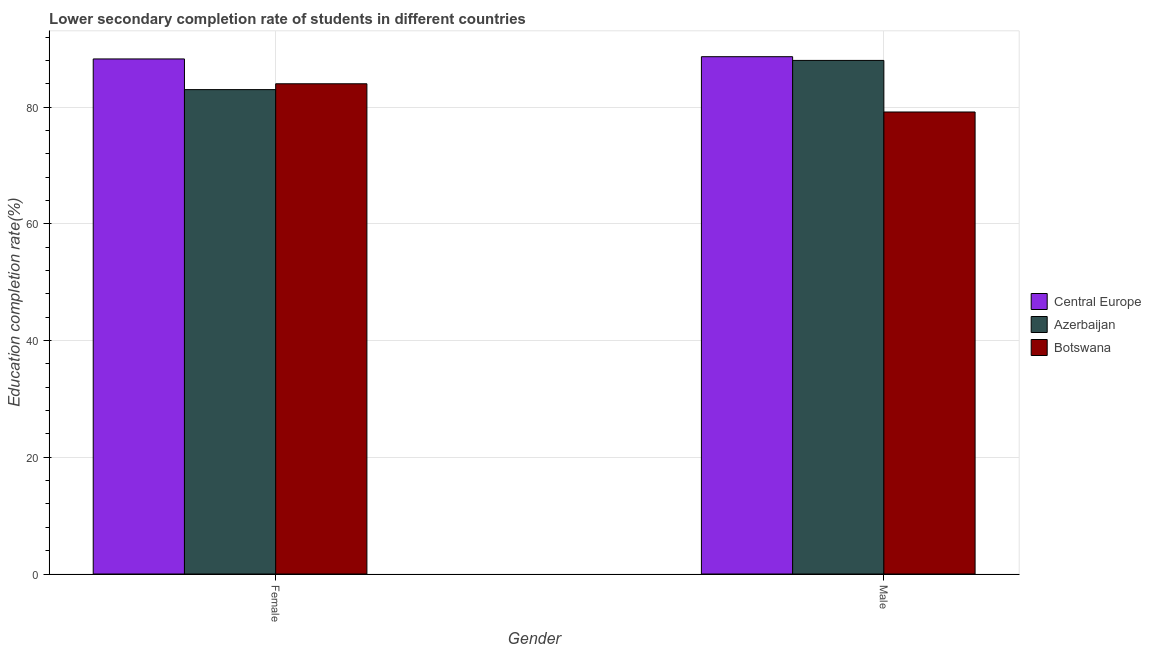How many groups of bars are there?
Ensure brevity in your answer.  2. Are the number of bars per tick equal to the number of legend labels?
Ensure brevity in your answer.  Yes. How many bars are there on the 2nd tick from the right?
Offer a terse response. 3. What is the education completion rate of male students in Central Europe?
Your response must be concise. 88.65. Across all countries, what is the maximum education completion rate of female students?
Keep it short and to the point. 88.26. Across all countries, what is the minimum education completion rate of female students?
Provide a short and direct response. 83.01. In which country was the education completion rate of female students maximum?
Offer a very short reply. Central Europe. In which country was the education completion rate of male students minimum?
Keep it short and to the point. Botswana. What is the total education completion rate of female students in the graph?
Keep it short and to the point. 255.27. What is the difference between the education completion rate of female students in Botswana and that in Central Europe?
Make the answer very short. -4.25. What is the difference between the education completion rate of male students in Central Europe and the education completion rate of female students in Azerbaijan?
Keep it short and to the point. 5.64. What is the average education completion rate of female students per country?
Give a very brief answer. 85.09. What is the difference between the education completion rate of male students and education completion rate of female students in Azerbaijan?
Your answer should be very brief. 5. In how many countries, is the education completion rate of male students greater than 72 %?
Make the answer very short. 3. What is the ratio of the education completion rate of male students in Central Europe to that in Azerbaijan?
Keep it short and to the point. 1.01. Is the education completion rate of male students in Central Europe less than that in Azerbaijan?
Make the answer very short. No. In how many countries, is the education completion rate of male students greater than the average education completion rate of male students taken over all countries?
Your answer should be compact. 2. What does the 2nd bar from the left in Female represents?
Provide a short and direct response. Azerbaijan. What does the 2nd bar from the right in Male represents?
Your answer should be compact. Azerbaijan. How many bars are there?
Provide a succinct answer. 6. Does the graph contain grids?
Provide a short and direct response. Yes. How are the legend labels stacked?
Make the answer very short. Vertical. What is the title of the graph?
Make the answer very short. Lower secondary completion rate of students in different countries. Does "Middle income" appear as one of the legend labels in the graph?
Offer a terse response. No. What is the label or title of the Y-axis?
Your response must be concise. Education completion rate(%). What is the Education completion rate(%) of Central Europe in Female?
Offer a very short reply. 88.26. What is the Education completion rate(%) in Azerbaijan in Female?
Provide a short and direct response. 83.01. What is the Education completion rate(%) of Botswana in Female?
Keep it short and to the point. 84.01. What is the Education completion rate(%) of Central Europe in Male?
Your answer should be compact. 88.65. What is the Education completion rate(%) of Azerbaijan in Male?
Ensure brevity in your answer.  88.01. What is the Education completion rate(%) in Botswana in Male?
Make the answer very short. 79.17. Across all Gender, what is the maximum Education completion rate(%) in Central Europe?
Provide a short and direct response. 88.65. Across all Gender, what is the maximum Education completion rate(%) in Azerbaijan?
Offer a very short reply. 88.01. Across all Gender, what is the maximum Education completion rate(%) of Botswana?
Offer a very short reply. 84.01. Across all Gender, what is the minimum Education completion rate(%) of Central Europe?
Your response must be concise. 88.26. Across all Gender, what is the minimum Education completion rate(%) of Azerbaijan?
Your answer should be very brief. 83.01. Across all Gender, what is the minimum Education completion rate(%) in Botswana?
Your answer should be very brief. 79.17. What is the total Education completion rate(%) of Central Europe in the graph?
Keep it short and to the point. 176.91. What is the total Education completion rate(%) in Azerbaijan in the graph?
Make the answer very short. 171.01. What is the total Education completion rate(%) in Botswana in the graph?
Your answer should be very brief. 163.17. What is the difference between the Education completion rate(%) of Central Europe in Female and that in Male?
Provide a succinct answer. -0.39. What is the difference between the Education completion rate(%) in Azerbaijan in Female and that in Male?
Give a very brief answer. -5. What is the difference between the Education completion rate(%) in Botswana in Female and that in Male?
Offer a terse response. 4.84. What is the difference between the Education completion rate(%) of Central Europe in Female and the Education completion rate(%) of Azerbaijan in Male?
Your answer should be compact. 0.25. What is the difference between the Education completion rate(%) of Central Europe in Female and the Education completion rate(%) of Botswana in Male?
Ensure brevity in your answer.  9.09. What is the difference between the Education completion rate(%) of Azerbaijan in Female and the Education completion rate(%) of Botswana in Male?
Provide a short and direct response. 3.84. What is the average Education completion rate(%) of Central Europe per Gender?
Offer a very short reply. 88.45. What is the average Education completion rate(%) in Azerbaijan per Gender?
Offer a terse response. 85.51. What is the average Education completion rate(%) of Botswana per Gender?
Provide a short and direct response. 81.59. What is the difference between the Education completion rate(%) in Central Europe and Education completion rate(%) in Azerbaijan in Female?
Ensure brevity in your answer.  5.26. What is the difference between the Education completion rate(%) of Central Europe and Education completion rate(%) of Botswana in Female?
Give a very brief answer. 4.25. What is the difference between the Education completion rate(%) of Azerbaijan and Education completion rate(%) of Botswana in Female?
Give a very brief answer. -1. What is the difference between the Education completion rate(%) in Central Europe and Education completion rate(%) in Azerbaijan in Male?
Your answer should be compact. 0.64. What is the difference between the Education completion rate(%) of Central Europe and Education completion rate(%) of Botswana in Male?
Your answer should be very brief. 9.48. What is the difference between the Education completion rate(%) of Azerbaijan and Education completion rate(%) of Botswana in Male?
Your answer should be compact. 8.84. What is the ratio of the Education completion rate(%) in Azerbaijan in Female to that in Male?
Keep it short and to the point. 0.94. What is the ratio of the Education completion rate(%) in Botswana in Female to that in Male?
Ensure brevity in your answer.  1.06. What is the difference between the highest and the second highest Education completion rate(%) in Central Europe?
Offer a terse response. 0.39. What is the difference between the highest and the second highest Education completion rate(%) in Azerbaijan?
Provide a succinct answer. 5. What is the difference between the highest and the second highest Education completion rate(%) of Botswana?
Your answer should be compact. 4.84. What is the difference between the highest and the lowest Education completion rate(%) in Central Europe?
Make the answer very short. 0.39. What is the difference between the highest and the lowest Education completion rate(%) of Azerbaijan?
Provide a short and direct response. 5. What is the difference between the highest and the lowest Education completion rate(%) in Botswana?
Give a very brief answer. 4.84. 